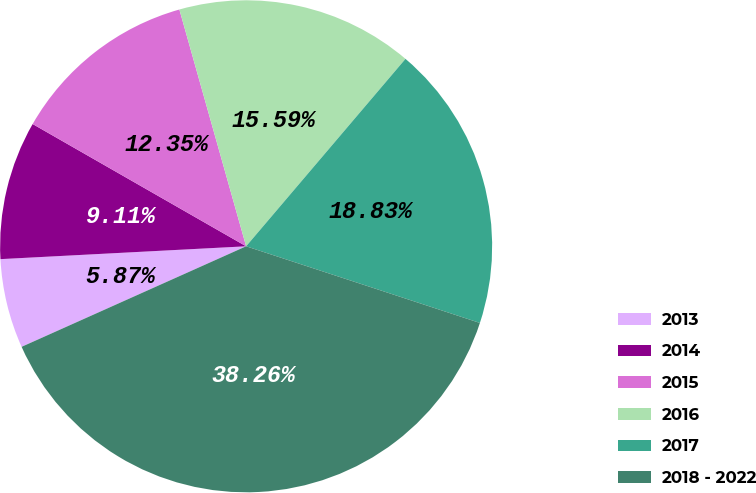Convert chart to OTSL. <chart><loc_0><loc_0><loc_500><loc_500><pie_chart><fcel>2013<fcel>2014<fcel>2015<fcel>2016<fcel>2017<fcel>2018 - 2022<nl><fcel>5.87%<fcel>9.11%<fcel>12.35%<fcel>15.59%<fcel>18.83%<fcel>38.26%<nl></chart> 